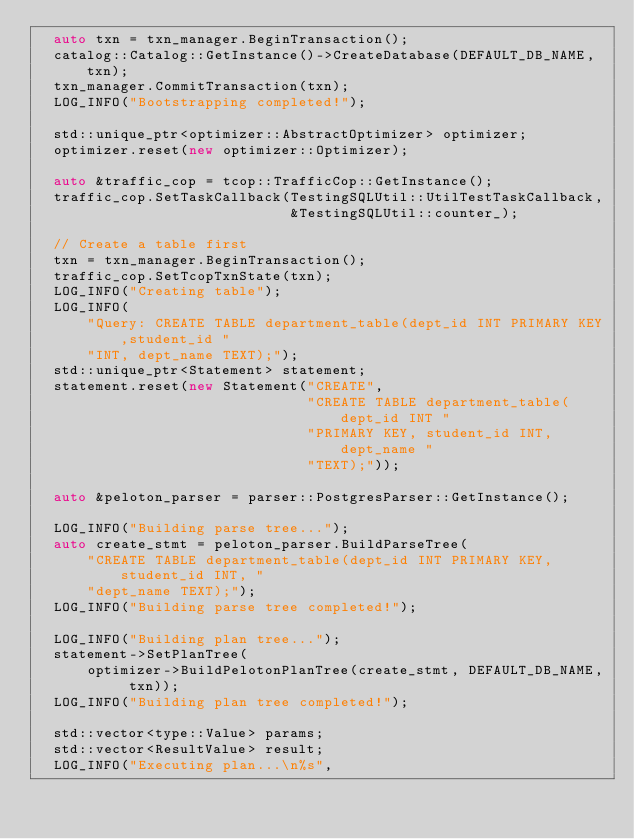Convert code to text. <code><loc_0><loc_0><loc_500><loc_500><_C++_>  auto txn = txn_manager.BeginTransaction();
  catalog::Catalog::GetInstance()->CreateDatabase(DEFAULT_DB_NAME, txn);
  txn_manager.CommitTransaction(txn);
  LOG_INFO("Bootstrapping completed!");

  std::unique_ptr<optimizer::AbstractOptimizer> optimizer;
  optimizer.reset(new optimizer::Optimizer);

  auto &traffic_cop = tcop::TrafficCop::GetInstance();
  traffic_cop.SetTaskCallback(TestingSQLUtil::UtilTestTaskCallback,
                              &TestingSQLUtil::counter_);

  // Create a table first
  txn = txn_manager.BeginTransaction();
  traffic_cop.SetTcopTxnState(txn);
  LOG_INFO("Creating table");
  LOG_INFO(
      "Query: CREATE TABLE department_table(dept_id INT PRIMARY KEY,student_id "
      "INT, dept_name TEXT);");
  std::unique_ptr<Statement> statement;
  statement.reset(new Statement("CREATE",
                                "CREATE TABLE department_table(dept_id INT "
                                "PRIMARY KEY, student_id INT, dept_name "
                                "TEXT);"));

  auto &peloton_parser = parser::PostgresParser::GetInstance();

  LOG_INFO("Building parse tree...");
  auto create_stmt = peloton_parser.BuildParseTree(
      "CREATE TABLE department_table(dept_id INT PRIMARY KEY, student_id INT, "
      "dept_name TEXT);");
  LOG_INFO("Building parse tree completed!");

  LOG_INFO("Building plan tree...");
  statement->SetPlanTree(
      optimizer->BuildPelotonPlanTree(create_stmt, DEFAULT_DB_NAME, txn));
  LOG_INFO("Building plan tree completed!");

  std::vector<type::Value> params;
  std::vector<ResultValue> result;
  LOG_INFO("Executing plan...\n%s",</code> 